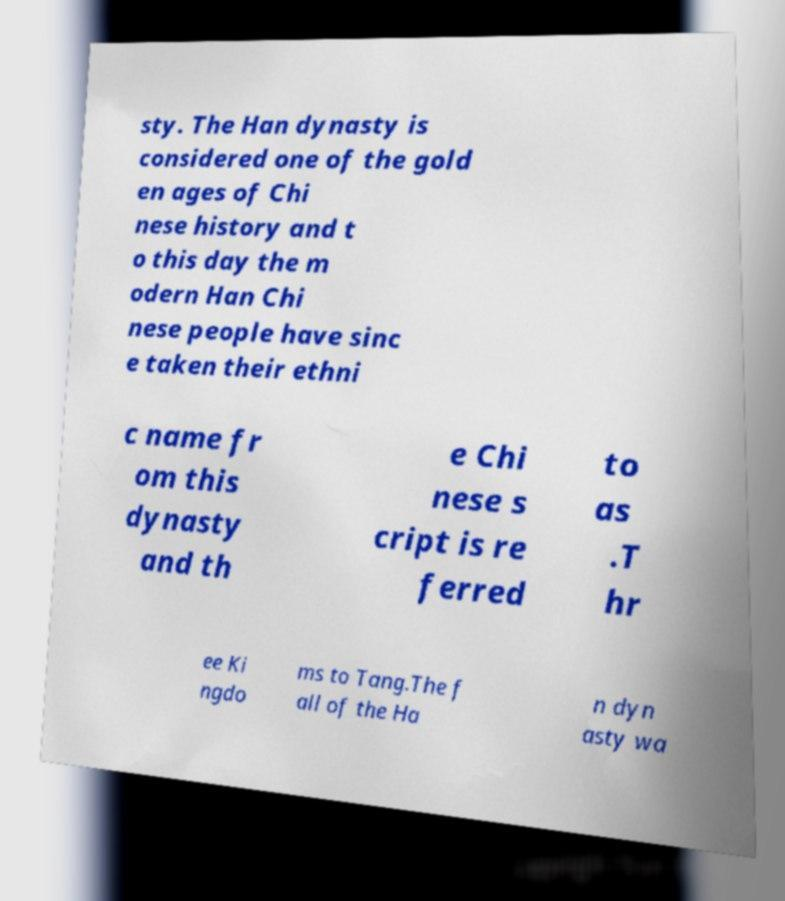Please identify and transcribe the text found in this image. sty. The Han dynasty is considered one of the gold en ages of Chi nese history and t o this day the m odern Han Chi nese people have sinc e taken their ethni c name fr om this dynasty and th e Chi nese s cript is re ferred to as .T hr ee Ki ngdo ms to Tang.The f all of the Ha n dyn asty wa 